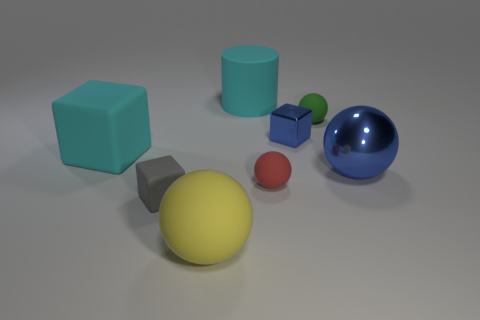What is the arrangement of objects based on their height? From tallest to shortest, the objects are arranged with the cyan cylinder being the tallest, followed by the blue and green cubes which are of equal height. Next in descending order are the blue sphere, yellow sphere, and red sphere, and finally, the smallest green and blue spheres. 